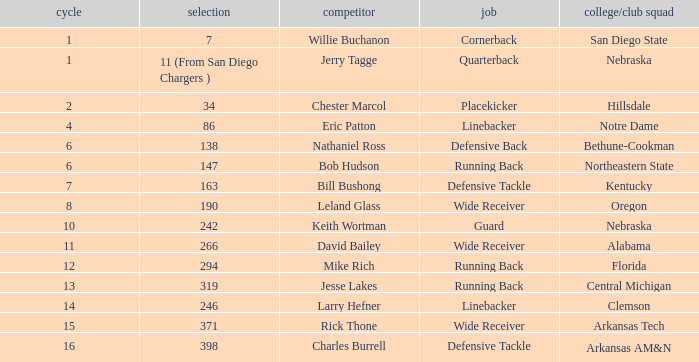Which round has a position that is cornerback? 1.0. Would you be able to parse every entry in this table? {'header': ['cycle', 'selection', 'competitor', 'job', 'college/club squad'], 'rows': [['1', '7', 'Willie Buchanon', 'Cornerback', 'San Diego State'], ['1', '11 (From San Diego Chargers )', 'Jerry Tagge', 'Quarterback', 'Nebraska'], ['2', '34', 'Chester Marcol', 'Placekicker', 'Hillsdale'], ['4', '86', 'Eric Patton', 'Linebacker', 'Notre Dame'], ['6', '138', 'Nathaniel Ross', 'Defensive Back', 'Bethune-Cookman'], ['6', '147', 'Bob Hudson', 'Running Back', 'Northeastern State'], ['7', '163', 'Bill Bushong', 'Defensive Tackle', 'Kentucky'], ['8', '190', 'Leland Glass', 'Wide Receiver', 'Oregon'], ['10', '242', 'Keith Wortman', 'Guard', 'Nebraska'], ['11', '266', 'David Bailey', 'Wide Receiver', 'Alabama'], ['12', '294', 'Mike Rich', 'Running Back', 'Florida'], ['13', '319', 'Jesse Lakes', 'Running Back', 'Central Michigan'], ['14', '246', 'Larry Hefner', 'Linebacker', 'Clemson'], ['15', '371', 'Rick Thone', 'Wide Receiver', 'Arkansas Tech'], ['16', '398', 'Charles Burrell', 'Defensive Tackle', 'Arkansas AM&N']]} 